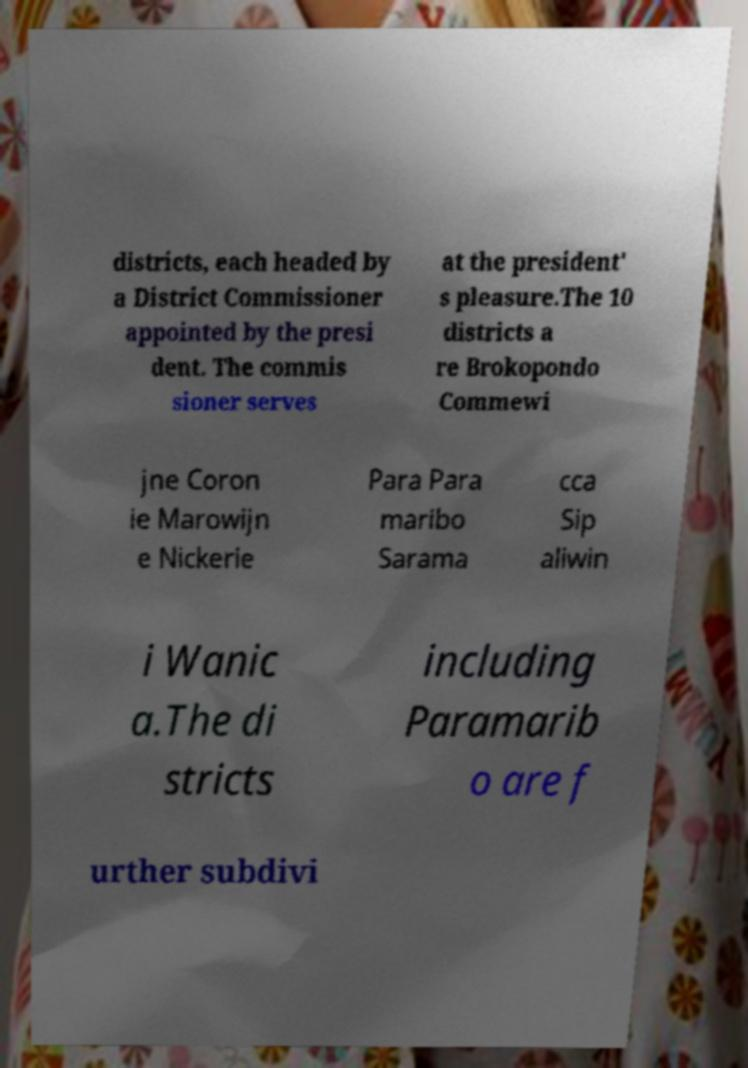Can you accurately transcribe the text from the provided image for me? districts, each headed by a District Commissioner appointed by the presi dent. The commis sioner serves at the president' s pleasure.The 10 districts a re Brokopondo Commewi jne Coron ie Marowijn e Nickerie Para Para maribo Sarama cca Sip aliwin i Wanic a.The di stricts including Paramarib o are f urther subdivi 